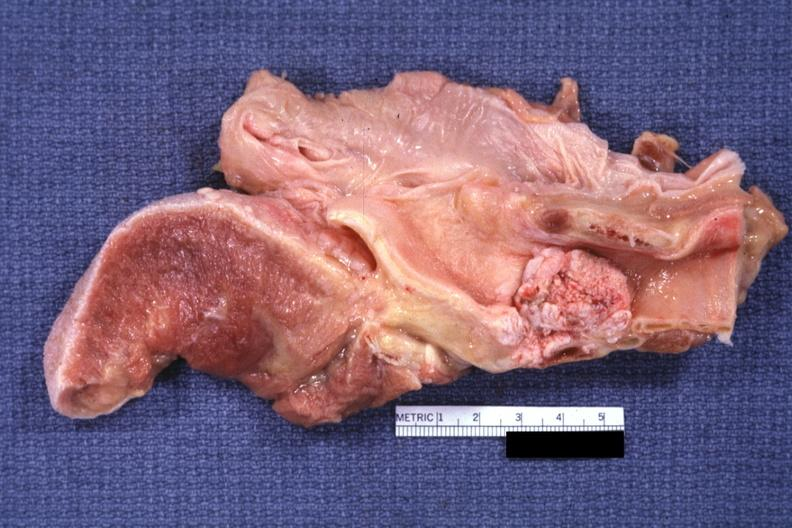where is this?
Answer the question using a single word or phrase. Oral 